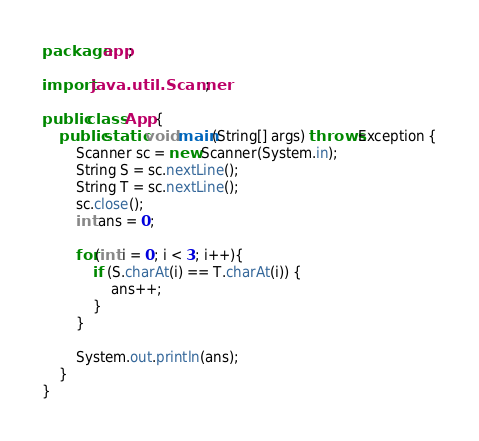Convert code to text. <code><loc_0><loc_0><loc_500><loc_500><_Java_>package app;

import java.util.Scanner;

public class App {
    public static void main(String[] args) throws Exception {
        Scanner sc = new Scanner(System.in);
        String S = sc.nextLine();
        String T = sc.nextLine();
        sc.close();
        int ans = 0;

        for(int i = 0; i < 3; i++){
            if (S.charAt(i) == T.charAt(i)) {
                ans++;
            }
        }

        System.out.println(ans);
    }
}</code> 